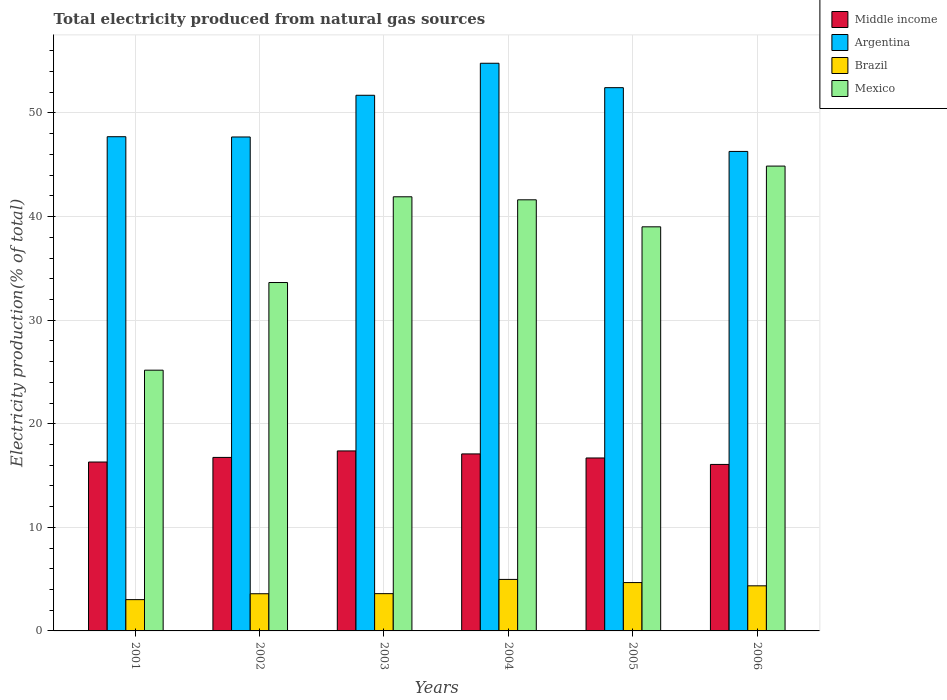How many different coloured bars are there?
Provide a succinct answer. 4. How many groups of bars are there?
Keep it short and to the point. 6. Are the number of bars per tick equal to the number of legend labels?
Ensure brevity in your answer.  Yes. Are the number of bars on each tick of the X-axis equal?
Give a very brief answer. Yes. In how many cases, is the number of bars for a given year not equal to the number of legend labels?
Your response must be concise. 0. What is the total electricity produced in Mexico in 2004?
Provide a short and direct response. 41.62. Across all years, what is the maximum total electricity produced in Argentina?
Your answer should be compact. 54.8. Across all years, what is the minimum total electricity produced in Argentina?
Keep it short and to the point. 46.29. In which year was the total electricity produced in Mexico maximum?
Make the answer very short. 2006. What is the total total electricity produced in Argentina in the graph?
Provide a succinct answer. 300.64. What is the difference between the total electricity produced in Brazil in 2001 and that in 2005?
Your answer should be very brief. -1.65. What is the difference between the total electricity produced in Brazil in 2001 and the total electricity produced in Argentina in 2004?
Provide a short and direct response. -51.78. What is the average total electricity produced in Mexico per year?
Provide a succinct answer. 37.7. In the year 2004, what is the difference between the total electricity produced in Argentina and total electricity produced in Mexico?
Offer a very short reply. 13.18. What is the ratio of the total electricity produced in Brazil in 2004 to that in 2005?
Offer a terse response. 1.07. Is the total electricity produced in Mexico in 2002 less than that in 2004?
Provide a short and direct response. Yes. What is the difference between the highest and the second highest total electricity produced in Argentina?
Provide a short and direct response. 2.36. What is the difference between the highest and the lowest total electricity produced in Middle income?
Make the answer very short. 1.3. Is the sum of the total electricity produced in Brazil in 2001 and 2005 greater than the maximum total electricity produced in Mexico across all years?
Make the answer very short. No. What does the 3rd bar from the left in 2003 represents?
Provide a succinct answer. Brazil. How many bars are there?
Keep it short and to the point. 24. Does the graph contain any zero values?
Provide a succinct answer. No. Where does the legend appear in the graph?
Make the answer very short. Top right. How many legend labels are there?
Your answer should be compact. 4. What is the title of the graph?
Your answer should be very brief. Total electricity produced from natural gas sources. Does "Ghana" appear as one of the legend labels in the graph?
Offer a terse response. No. What is the label or title of the X-axis?
Your answer should be very brief. Years. What is the label or title of the Y-axis?
Provide a short and direct response. Electricity production(% of total). What is the Electricity production(% of total) in Middle income in 2001?
Make the answer very short. 16.31. What is the Electricity production(% of total) of Argentina in 2001?
Your response must be concise. 47.71. What is the Electricity production(% of total) of Brazil in 2001?
Offer a terse response. 3.02. What is the Electricity production(% of total) in Mexico in 2001?
Offer a very short reply. 25.17. What is the Electricity production(% of total) in Middle income in 2002?
Provide a short and direct response. 16.75. What is the Electricity production(% of total) of Argentina in 2002?
Provide a short and direct response. 47.68. What is the Electricity production(% of total) of Brazil in 2002?
Keep it short and to the point. 3.59. What is the Electricity production(% of total) in Mexico in 2002?
Provide a short and direct response. 33.63. What is the Electricity production(% of total) of Middle income in 2003?
Your answer should be very brief. 17.38. What is the Electricity production(% of total) in Argentina in 2003?
Offer a very short reply. 51.71. What is the Electricity production(% of total) of Brazil in 2003?
Offer a terse response. 3.6. What is the Electricity production(% of total) of Mexico in 2003?
Your answer should be very brief. 41.91. What is the Electricity production(% of total) of Middle income in 2004?
Keep it short and to the point. 17.09. What is the Electricity production(% of total) of Argentina in 2004?
Your response must be concise. 54.8. What is the Electricity production(% of total) of Brazil in 2004?
Offer a terse response. 4.97. What is the Electricity production(% of total) in Mexico in 2004?
Provide a succinct answer. 41.62. What is the Electricity production(% of total) of Middle income in 2005?
Offer a terse response. 16.7. What is the Electricity production(% of total) in Argentina in 2005?
Your answer should be very brief. 52.45. What is the Electricity production(% of total) of Brazil in 2005?
Your answer should be compact. 4.67. What is the Electricity production(% of total) in Mexico in 2005?
Your answer should be very brief. 39.01. What is the Electricity production(% of total) of Middle income in 2006?
Provide a succinct answer. 16.07. What is the Electricity production(% of total) in Argentina in 2006?
Your answer should be compact. 46.29. What is the Electricity production(% of total) in Brazil in 2006?
Offer a very short reply. 4.35. What is the Electricity production(% of total) in Mexico in 2006?
Offer a terse response. 44.88. Across all years, what is the maximum Electricity production(% of total) of Middle income?
Provide a short and direct response. 17.38. Across all years, what is the maximum Electricity production(% of total) in Argentina?
Offer a terse response. 54.8. Across all years, what is the maximum Electricity production(% of total) in Brazil?
Ensure brevity in your answer.  4.97. Across all years, what is the maximum Electricity production(% of total) in Mexico?
Give a very brief answer. 44.88. Across all years, what is the minimum Electricity production(% of total) in Middle income?
Keep it short and to the point. 16.07. Across all years, what is the minimum Electricity production(% of total) in Argentina?
Make the answer very short. 46.29. Across all years, what is the minimum Electricity production(% of total) in Brazil?
Provide a succinct answer. 3.02. Across all years, what is the minimum Electricity production(% of total) of Mexico?
Give a very brief answer. 25.17. What is the total Electricity production(% of total) of Middle income in the graph?
Give a very brief answer. 100.29. What is the total Electricity production(% of total) of Argentina in the graph?
Make the answer very short. 300.64. What is the total Electricity production(% of total) of Brazil in the graph?
Offer a terse response. 24.2. What is the total Electricity production(% of total) in Mexico in the graph?
Offer a very short reply. 226.22. What is the difference between the Electricity production(% of total) in Middle income in 2001 and that in 2002?
Provide a succinct answer. -0.44. What is the difference between the Electricity production(% of total) of Argentina in 2001 and that in 2002?
Your answer should be very brief. 0.03. What is the difference between the Electricity production(% of total) of Brazil in 2001 and that in 2002?
Ensure brevity in your answer.  -0.57. What is the difference between the Electricity production(% of total) of Mexico in 2001 and that in 2002?
Ensure brevity in your answer.  -8.46. What is the difference between the Electricity production(% of total) of Middle income in 2001 and that in 2003?
Provide a succinct answer. -1.07. What is the difference between the Electricity production(% of total) of Argentina in 2001 and that in 2003?
Your response must be concise. -4. What is the difference between the Electricity production(% of total) of Brazil in 2001 and that in 2003?
Ensure brevity in your answer.  -0.58. What is the difference between the Electricity production(% of total) of Mexico in 2001 and that in 2003?
Your answer should be compact. -16.74. What is the difference between the Electricity production(% of total) of Middle income in 2001 and that in 2004?
Provide a succinct answer. -0.78. What is the difference between the Electricity production(% of total) in Argentina in 2001 and that in 2004?
Your answer should be very brief. -7.09. What is the difference between the Electricity production(% of total) of Brazil in 2001 and that in 2004?
Offer a terse response. -1.95. What is the difference between the Electricity production(% of total) of Mexico in 2001 and that in 2004?
Offer a very short reply. -16.45. What is the difference between the Electricity production(% of total) of Middle income in 2001 and that in 2005?
Offer a very short reply. -0.39. What is the difference between the Electricity production(% of total) in Argentina in 2001 and that in 2005?
Offer a terse response. -4.73. What is the difference between the Electricity production(% of total) in Brazil in 2001 and that in 2005?
Offer a terse response. -1.65. What is the difference between the Electricity production(% of total) of Mexico in 2001 and that in 2005?
Your answer should be compact. -13.84. What is the difference between the Electricity production(% of total) of Middle income in 2001 and that in 2006?
Ensure brevity in your answer.  0.23. What is the difference between the Electricity production(% of total) in Argentina in 2001 and that in 2006?
Your response must be concise. 1.42. What is the difference between the Electricity production(% of total) of Brazil in 2001 and that in 2006?
Your answer should be compact. -1.33. What is the difference between the Electricity production(% of total) in Mexico in 2001 and that in 2006?
Your answer should be very brief. -19.7. What is the difference between the Electricity production(% of total) of Middle income in 2002 and that in 2003?
Your response must be concise. -0.63. What is the difference between the Electricity production(% of total) of Argentina in 2002 and that in 2003?
Ensure brevity in your answer.  -4.03. What is the difference between the Electricity production(% of total) of Brazil in 2002 and that in 2003?
Offer a terse response. -0.01. What is the difference between the Electricity production(% of total) of Mexico in 2002 and that in 2003?
Provide a short and direct response. -8.28. What is the difference between the Electricity production(% of total) of Middle income in 2002 and that in 2004?
Your answer should be very brief. -0.34. What is the difference between the Electricity production(% of total) of Argentina in 2002 and that in 2004?
Offer a very short reply. -7.12. What is the difference between the Electricity production(% of total) of Brazil in 2002 and that in 2004?
Ensure brevity in your answer.  -1.38. What is the difference between the Electricity production(% of total) in Mexico in 2002 and that in 2004?
Your response must be concise. -7.98. What is the difference between the Electricity production(% of total) in Middle income in 2002 and that in 2005?
Your response must be concise. 0.05. What is the difference between the Electricity production(% of total) in Argentina in 2002 and that in 2005?
Provide a succinct answer. -4.76. What is the difference between the Electricity production(% of total) in Brazil in 2002 and that in 2005?
Ensure brevity in your answer.  -1.08. What is the difference between the Electricity production(% of total) in Mexico in 2002 and that in 2005?
Your answer should be very brief. -5.38. What is the difference between the Electricity production(% of total) in Middle income in 2002 and that in 2006?
Your answer should be compact. 0.68. What is the difference between the Electricity production(% of total) in Argentina in 2002 and that in 2006?
Your response must be concise. 1.39. What is the difference between the Electricity production(% of total) in Brazil in 2002 and that in 2006?
Your answer should be compact. -0.77. What is the difference between the Electricity production(% of total) in Mexico in 2002 and that in 2006?
Ensure brevity in your answer.  -11.24. What is the difference between the Electricity production(% of total) in Middle income in 2003 and that in 2004?
Make the answer very short. 0.29. What is the difference between the Electricity production(% of total) in Argentina in 2003 and that in 2004?
Keep it short and to the point. -3.09. What is the difference between the Electricity production(% of total) in Brazil in 2003 and that in 2004?
Give a very brief answer. -1.37. What is the difference between the Electricity production(% of total) of Mexico in 2003 and that in 2004?
Provide a short and direct response. 0.29. What is the difference between the Electricity production(% of total) in Middle income in 2003 and that in 2005?
Your answer should be compact. 0.68. What is the difference between the Electricity production(% of total) of Argentina in 2003 and that in 2005?
Make the answer very short. -0.74. What is the difference between the Electricity production(% of total) in Brazil in 2003 and that in 2005?
Your answer should be very brief. -1.07. What is the difference between the Electricity production(% of total) in Mexico in 2003 and that in 2005?
Provide a short and direct response. 2.9. What is the difference between the Electricity production(% of total) in Middle income in 2003 and that in 2006?
Ensure brevity in your answer.  1.3. What is the difference between the Electricity production(% of total) of Argentina in 2003 and that in 2006?
Offer a very short reply. 5.42. What is the difference between the Electricity production(% of total) of Brazil in 2003 and that in 2006?
Provide a short and direct response. -0.76. What is the difference between the Electricity production(% of total) in Mexico in 2003 and that in 2006?
Your answer should be compact. -2.96. What is the difference between the Electricity production(% of total) in Middle income in 2004 and that in 2005?
Your answer should be very brief. 0.39. What is the difference between the Electricity production(% of total) in Argentina in 2004 and that in 2005?
Provide a succinct answer. 2.36. What is the difference between the Electricity production(% of total) in Brazil in 2004 and that in 2005?
Your response must be concise. 0.3. What is the difference between the Electricity production(% of total) in Mexico in 2004 and that in 2005?
Provide a short and direct response. 2.61. What is the difference between the Electricity production(% of total) in Middle income in 2004 and that in 2006?
Your response must be concise. 1.02. What is the difference between the Electricity production(% of total) in Argentina in 2004 and that in 2006?
Your answer should be compact. 8.51. What is the difference between the Electricity production(% of total) in Brazil in 2004 and that in 2006?
Your response must be concise. 0.62. What is the difference between the Electricity production(% of total) of Mexico in 2004 and that in 2006?
Ensure brevity in your answer.  -3.26. What is the difference between the Electricity production(% of total) of Middle income in 2005 and that in 2006?
Keep it short and to the point. 0.62. What is the difference between the Electricity production(% of total) of Argentina in 2005 and that in 2006?
Offer a very short reply. 6.16. What is the difference between the Electricity production(% of total) in Brazil in 2005 and that in 2006?
Provide a succinct answer. 0.31. What is the difference between the Electricity production(% of total) of Mexico in 2005 and that in 2006?
Offer a very short reply. -5.86. What is the difference between the Electricity production(% of total) in Middle income in 2001 and the Electricity production(% of total) in Argentina in 2002?
Ensure brevity in your answer.  -31.38. What is the difference between the Electricity production(% of total) in Middle income in 2001 and the Electricity production(% of total) in Brazil in 2002?
Ensure brevity in your answer.  12.72. What is the difference between the Electricity production(% of total) of Middle income in 2001 and the Electricity production(% of total) of Mexico in 2002?
Keep it short and to the point. -17.33. What is the difference between the Electricity production(% of total) in Argentina in 2001 and the Electricity production(% of total) in Brazil in 2002?
Your answer should be very brief. 44.12. What is the difference between the Electricity production(% of total) in Argentina in 2001 and the Electricity production(% of total) in Mexico in 2002?
Your answer should be very brief. 14.08. What is the difference between the Electricity production(% of total) in Brazil in 2001 and the Electricity production(% of total) in Mexico in 2002?
Keep it short and to the point. -30.61. What is the difference between the Electricity production(% of total) in Middle income in 2001 and the Electricity production(% of total) in Argentina in 2003?
Your answer should be very brief. -35.4. What is the difference between the Electricity production(% of total) of Middle income in 2001 and the Electricity production(% of total) of Brazil in 2003?
Make the answer very short. 12.71. What is the difference between the Electricity production(% of total) of Middle income in 2001 and the Electricity production(% of total) of Mexico in 2003?
Provide a short and direct response. -25.61. What is the difference between the Electricity production(% of total) in Argentina in 2001 and the Electricity production(% of total) in Brazil in 2003?
Ensure brevity in your answer.  44.11. What is the difference between the Electricity production(% of total) in Brazil in 2001 and the Electricity production(% of total) in Mexico in 2003?
Provide a short and direct response. -38.89. What is the difference between the Electricity production(% of total) in Middle income in 2001 and the Electricity production(% of total) in Argentina in 2004?
Provide a succinct answer. -38.5. What is the difference between the Electricity production(% of total) in Middle income in 2001 and the Electricity production(% of total) in Brazil in 2004?
Ensure brevity in your answer.  11.33. What is the difference between the Electricity production(% of total) in Middle income in 2001 and the Electricity production(% of total) in Mexico in 2004?
Your response must be concise. -25.31. What is the difference between the Electricity production(% of total) in Argentina in 2001 and the Electricity production(% of total) in Brazil in 2004?
Offer a terse response. 42.74. What is the difference between the Electricity production(% of total) of Argentina in 2001 and the Electricity production(% of total) of Mexico in 2004?
Ensure brevity in your answer.  6.09. What is the difference between the Electricity production(% of total) of Brazil in 2001 and the Electricity production(% of total) of Mexico in 2004?
Offer a terse response. -38.6. What is the difference between the Electricity production(% of total) in Middle income in 2001 and the Electricity production(% of total) in Argentina in 2005?
Ensure brevity in your answer.  -36.14. What is the difference between the Electricity production(% of total) of Middle income in 2001 and the Electricity production(% of total) of Brazil in 2005?
Give a very brief answer. 11.64. What is the difference between the Electricity production(% of total) of Middle income in 2001 and the Electricity production(% of total) of Mexico in 2005?
Your answer should be very brief. -22.71. What is the difference between the Electricity production(% of total) in Argentina in 2001 and the Electricity production(% of total) in Brazil in 2005?
Make the answer very short. 43.04. What is the difference between the Electricity production(% of total) in Argentina in 2001 and the Electricity production(% of total) in Mexico in 2005?
Offer a terse response. 8.7. What is the difference between the Electricity production(% of total) in Brazil in 2001 and the Electricity production(% of total) in Mexico in 2005?
Provide a succinct answer. -35.99. What is the difference between the Electricity production(% of total) in Middle income in 2001 and the Electricity production(% of total) in Argentina in 2006?
Provide a short and direct response. -29.98. What is the difference between the Electricity production(% of total) of Middle income in 2001 and the Electricity production(% of total) of Brazil in 2006?
Your response must be concise. 11.95. What is the difference between the Electricity production(% of total) of Middle income in 2001 and the Electricity production(% of total) of Mexico in 2006?
Offer a terse response. -28.57. What is the difference between the Electricity production(% of total) of Argentina in 2001 and the Electricity production(% of total) of Brazil in 2006?
Your response must be concise. 43.36. What is the difference between the Electricity production(% of total) in Argentina in 2001 and the Electricity production(% of total) in Mexico in 2006?
Provide a short and direct response. 2.84. What is the difference between the Electricity production(% of total) in Brazil in 2001 and the Electricity production(% of total) in Mexico in 2006?
Your answer should be compact. -41.85. What is the difference between the Electricity production(% of total) of Middle income in 2002 and the Electricity production(% of total) of Argentina in 2003?
Offer a very short reply. -34.96. What is the difference between the Electricity production(% of total) in Middle income in 2002 and the Electricity production(% of total) in Brazil in 2003?
Keep it short and to the point. 13.15. What is the difference between the Electricity production(% of total) of Middle income in 2002 and the Electricity production(% of total) of Mexico in 2003?
Give a very brief answer. -25.16. What is the difference between the Electricity production(% of total) of Argentina in 2002 and the Electricity production(% of total) of Brazil in 2003?
Offer a very short reply. 44.09. What is the difference between the Electricity production(% of total) of Argentina in 2002 and the Electricity production(% of total) of Mexico in 2003?
Offer a very short reply. 5.77. What is the difference between the Electricity production(% of total) of Brazil in 2002 and the Electricity production(% of total) of Mexico in 2003?
Ensure brevity in your answer.  -38.32. What is the difference between the Electricity production(% of total) in Middle income in 2002 and the Electricity production(% of total) in Argentina in 2004?
Offer a terse response. -38.05. What is the difference between the Electricity production(% of total) in Middle income in 2002 and the Electricity production(% of total) in Brazil in 2004?
Ensure brevity in your answer.  11.78. What is the difference between the Electricity production(% of total) in Middle income in 2002 and the Electricity production(% of total) in Mexico in 2004?
Provide a succinct answer. -24.87. What is the difference between the Electricity production(% of total) of Argentina in 2002 and the Electricity production(% of total) of Brazil in 2004?
Offer a very short reply. 42.71. What is the difference between the Electricity production(% of total) of Argentina in 2002 and the Electricity production(% of total) of Mexico in 2004?
Provide a succinct answer. 6.07. What is the difference between the Electricity production(% of total) of Brazil in 2002 and the Electricity production(% of total) of Mexico in 2004?
Your answer should be very brief. -38.03. What is the difference between the Electricity production(% of total) in Middle income in 2002 and the Electricity production(% of total) in Argentina in 2005?
Your response must be concise. -35.7. What is the difference between the Electricity production(% of total) in Middle income in 2002 and the Electricity production(% of total) in Brazil in 2005?
Ensure brevity in your answer.  12.08. What is the difference between the Electricity production(% of total) in Middle income in 2002 and the Electricity production(% of total) in Mexico in 2005?
Offer a very short reply. -22.26. What is the difference between the Electricity production(% of total) of Argentina in 2002 and the Electricity production(% of total) of Brazil in 2005?
Provide a short and direct response. 43.02. What is the difference between the Electricity production(% of total) in Argentina in 2002 and the Electricity production(% of total) in Mexico in 2005?
Make the answer very short. 8.67. What is the difference between the Electricity production(% of total) in Brazil in 2002 and the Electricity production(% of total) in Mexico in 2005?
Make the answer very short. -35.42. What is the difference between the Electricity production(% of total) in Middle income in 2002 and the Electricity production(% of total) in Argentina in 2006?
Keep it short and to the point. -29.54. What is the difference between the Electricity production(% of total) in Middle income in 2002 and the Electricity production(% of total) in Brazil in 2006?
Give a very brief answer. 12.4. What is the difference between the Electricity production(% of total) of Middle income in 2002 and the Electricity production(% of total) of Mexico in 2006?
Offer a terse response. -28.13. What is the difference between the Electricity production(% of total) of Argentina in 2002 and the Electricity production(% of total) of Brazil in 2006?
Provide a succinct answer. 43.33. What is the difference between the Electricity production(% of total) in Argentina in 2002 and the Electricity production(% of total) in Mexico in 2006?
Make the answer very short. 2.81. What is the difference between the Electricity production(% of total) in Brazil in 2002 and the Electricity production(% of total) in Mexico in 2006?
Your response must be concise. -41.29. What is the difference between the Electricity production(% of total) of Middle income in 2003 and the Electricity production(% of total) of Argentina in 2004?
Make the answer very short. -37.42. What is the difference between the Electricity production(% of total) in Middle income in 2003 and the Electricity production(% of total) in Brazil in 2004?
Provide a succinct answer. 12.4. What is the difference between the Electricity production(% of total) in Middle income in 2003 and the Electricity production(% of total) in Mexico in 2004?
Provide a short and direct response. -24.24. What is the difference between the Electricity production(% of total) in Argentina in 2003 and the Electricity production(% of total) in Brazil in 2004?
Offer a terse response. 46.74. What is the difference between the Electricity production(% of total) of Argentina in 2003 and the Electricity production(% of total) of Mexico in 2004?
Keep it short and to the point. 10.09. What is the difference between the Electricity production(% of total) of Brazil in 2003 and the Electricity production(% of total) of Mexico in 2004?
Your response must be concise. -38.02. What is the difference between the Electricity production(% of total) of Middle income in 2003 and the Electricity production(% of total) of Argentina in 2005?
Make the answer very short. -35.07. What is the difference between the Electricity production(% of total) in Middle income in 2003 and the Electricity production(% of total) in Brazil in 2005?
Your answer should be very brief. 12.71. What is the difference between the Electricity production(% of total) of Middle income in 2003 and the Electricity production(% of total) of Mexico in 2005?
Provide a succinct answer. -21.63. What is the difference between the Electricity production(% of total) of Argentina in 2003 and the Electricity production(% of total) of Brazil in 2005?
Offer a very short reply. 47.04. What is the difference between the Electricity production(% of total) of Argentina in 2003 and the Electricity production(% of total) of Mexico in 2005?
Provide a succinct answer. 12.7. What is the difference between the Electricity production(% of total) of Brazil in 2003 and the Electricity production(% of total) of Mexico in 2005?
Keep it short and to the point. -35.41. What is the difference between the Electricity production(% of total) in Middle income in 2003 and the Electricity production(% of total) in Argentina in 2006?
Your answer should be compact. -28.91. What is the difference between the Electricity production(% of total) in Middle income in 2003 and the Electricity production(% of total) in Brazil in 2006?
Ensure brevity in your answer.  13.02. What is the difference between the Electricity production(% of total) in Middle income in 2003 and the Electricity production(% of total) in Mexico in 2006?
Offer a terse response. -27.5. What is the difference between the Electricity production(% of total) in Argentina in 2003 and the Electricity production(% of total) in Brazil in 2006?
Offer a terse response. 47.36. What is the difference between the Electricity production(% of total) of Argentina in 2003 and the Electricity production(% of total) of Mexico in 2006?
Keep it short and to the point. 6.84. What is the difference between the Electricity production(% of total) of Brazil in 2003 and the Electricity production(% of total) of Mexico in 2006?
Ensure brevity in your answer.  -41.28. What is the difference between the Electricity production(% of total) of Middle income in 2004 and the Electricity production(% of total) of Argentina in 2005?
Your answer should be compact. -35.36. What is the difference between the Electricity production(% of total) in Middle income in 2004 and the Electricity production(% of total) in Brazil in 2005?
Your answer should be compact. 12.42. What is the difference between the Electricity production(% of total) in Middle income in 2004 and the Electricity production(% of total) in Mexico in 2005?
Provide a succinct answer. -21.92. What is the difference between the Electricity production(% of total) in Argentina in 2004 and the Electricity production(% of total) in Brazil in 2005?
Make the answer very short. 50.13. What is the difference between the Electricity production(% of total) in Argentina in 2004 and the Electricity production(% of total) in Mexico in 2005?
Offer a terse response. 15.79. What is the difference between the Electricity production(% of total) of Brazil in 2004 and the Electricity production(% of total) of Mexico in 2005?
Provide a short and direct response. -34.04. What is the difference between the Electricity production(% of total) of Middle income in 2004 and the Electricity production(% of total) of Argentina in 2006?
Your response must be concise. -29.2. What is the difference between the Electricity production(% of total) of Middle income in 2004 and the Electricity production(% of total) of Brazil in 2006?
Make the answer very short. 12.73. What is the difference between the Electricity production(% of total) of Middle income in 2004 and the Electricity production(% of total) of Mexico in 2006?
Ensure brevity in your answer.  -27.79. What is the difference between the Electricity production(% of total) of Argentina in 2004 and the Electricity production(% of total) of Brazil in 2006?
Keep it short and to the point. 50.45. What is the difference between the Electricity production(% of total) of Argentina in 2004 and the Electricity production(% of total) of Mexico in 2006?
Ensure brevity in your answer.  9.93. What is the difference between the Electricity production(% of total) in Brazil in 2004 and the Electricity production(% of total) in Mexico in 2006?
Your answer should be compact. -39.9. What is the difference between the Electricity production(% of total) of Middle income in 2005 and the Electricity production(% of total) of Argentina in 2006?
Ensure brevity in your answer.  -29.59. What is the difference between the Electricity production(% of total) of Middle income in 2005 and the Electricity production(% of total) of Brazil in 2006?
Offer a very short reply. 12.34. What is the difference between the Electricity production(% of total) in Middle income in 2005 and the Electricity production(% of total) in Mexico in 2006?
Offer a terse response. -28.18. What is the difference between the Electricity production(% of total) of Argentina in 2005 and the Electricity production(% of total) of Brazil in 2006?
Ensure brevity in your answer.  48.09. What is the difference between the Electricity production(% of total) in Argentina in 2005 and the Electricity production(% of total) in Mexico in 2006?
Ensure brevity in your answer.  7.57. What is the difference between the Electricity production(% of total) in Brazil in 2005 and the Electricity production(% of total) in Mexico in 2006?
Offer a very short reply. -40.21. What is the average Electricity production(% of total) in Middle income per year?
Give a very brief answer. 16.71. What is the average Electricity production(% of total) of Argentina per year?
Your answer should be compact. 50.11. What is the average Electricity production(% of total) of Brazil per year?
Your response must be concise. 4.03. What is the average Electricity production(% of total) in Mexico per year?
Ensure brevity in your answer.  37.7. In the year 2001, what is the difference between the Electricity production(% of total) in Middle income and Electricity production(% of total) in Argentina?
Make the answer very short. -31.41. In the year 2001, what is the difference between the Electricity production(% of total) of Middle income and Electricity production(% of total) of Brazil?
Provide a succinct answer. 13.29. In the year 2001, what is the difference between the Electricity production(% of total) in Middle income and Electricity production(% of total) in Mexico?
Make the answer very short. -8.87. In the year 2001, what is the difference between the Electricity production(% of total) of Argentina and Electricity production(% of total) of Brazil?
Provide a succinct answer. 44.69. In the year 2001, what is the difference between the Electricity production(% of total) in Argentina and Electricity production(% of total) in Mexico?
Your response must be concise. 22.54. In the year 2001, what is the difference between the Electricity production(% of total) of Brazil and Electricity production(% of total) of Mexico?
Ensure brevity in your answer.  -22.15. In the year 2002, what is the difference between the Electricity production(% of total) in Middle income and Electricity production(% of total) in Argentina?
Provide a short and direct response. -30.93. In the year 2002, what is the difference between the Electricity production(% of total) in Middle income and Electricity production(% of total) in Brazil?
Your response must be concise. 13.16. In the year 2002, what is the difference between the Electricity production(% of total) of Middle income and Electricity production(% of total) of Mexico?
Provide a succinct answer. -16.88. In the year 2002, what is the difference between the Electricity production(% of total) in Argentina and Electricity production(% of total) in Brazil?
Provide a succinct answer. 44.1. In the year 2002, what is the difference between the Electricity production(% of total) of Argentina and Electricity production(% of total) of Mexico?
Your answer should be compact. 14.05. In the year 2002, what is the difference between the Electricity production(% of total) of Brazil and Electricity production(% of total) of Mexico?
Your response must be concise. -30.05. In the year 2003, what is the difference between the Electricity production(% of total) of Middle income and Electricity production(% of total) of Argentina?
Provide a short and direct response. -34.33. In the year 2003, what is the difference between the Electricity production(% of total) of Middle income and Electricity production(% of total) of Brazil?
Offer a very short reply. 13.78. In the year 2003, what is the difference between the Electricity production(% of total) of Middle income and Electricity production(% of total) of Mexico?
Give a very brief answer. -24.53. In the year 2003, what is the difference between the Electricity production(% of total) in Argentina and Electricity production(% of total) in Brazil?
Offer a very short reply. 48.11. In the year 2003, what is the difference between the Electricity production(% of total) of Argentina and Electricity production(% of total) of Mexico?
Your answer should be very brief. 9.8. In the year 2003, what is the difference between the Electricity production(% of total) of Brazil and Electricity production(% of total) of Mexico?
Give a very brief answer. -38.31. In the year 2004, what is the difference between the Electricity production(% of total) of Middle income and Electricity production(% of total) of Argentina?
Your response must be concise. -37.71. In the year 2004, what is the difference between the Electricity production(% of total) in Middle income and Electricity production(% of total) in Brazil?
Your response must be concise. 12.12. In the year 2004, what is the difference between the Electricity production(% of total) of Middle income and Electricity production(% of total) of Mexico?
Ensure brevity in your answer.  -24.53. In the year 2004, what is the difference between the Electricity production(% of total) of Argentina and Electricity production(% of total) of Brazil?
Make the answer very short. 49.83. In the year 2004, what is the difference between the Electricity production(% of total) of Argentina and Electricity production(% of total) of Mexico?
Your answer should be very brief. 13.18. In the year 2004, what is the difference between the Electricity production(% of total) in Brazil and Electricity production(% of total) in Mexico?
Offer a terse response. -36.65. In the year 2005, what is the difference between the Electricity production(% of total) of Middle income and Electricity production(% of total) of Argentina?
Keep it short and to the point. -35.75. In the year 2005, what is the difference between the Electricity production(% of total) in Middle income and Electricity production(% of total) in Brazil?
Your answer should be compact. 12.03. In the year 2005, what is the difference between the Electricity production(% of total) of Middle income and Electricity production(% of total) of Mexico?
Keep it short and to the point. -22.31. In the year 2005, what is the difference between the Electricity production(% of total) in Argentina and Electricity production(% of total) in Brazil?
Keep it short and to the point. 47.78. In the year 2005, what is the difference between the Electricity production(% of total) of Argentina and Electricity production(% of total) of Mexico?
Keep it short and to the point. 13.44. In the year 2005, what is the difference between the Electricity production(% of total) of Brazil and Electricity production(% of total) of Mexico?
Provide a succinct answer. -34.34. In the year 2006, what is the difference between the Electricity production(% of total) of Middle income and Electricity production(% of total) of Argentina?
Your answer should be compact. -30.22. In the year 2006, what is the difference between the Electricity production(% of total) in Middle income and Electricity production(% of total) in Brazil?
Keep it short and to the point. 11.72. In the year 2006, what is the difference between the Electricity production(% of total) in Middle income and Electricity production(% of total) in Mexico?
Your answer should be very brief. -28.8. In the year 2006, what is the difference between the Electricity production(% of total) in Argentina and Electricity production(% of total) in Brazil?
Offer a very short reply. 41.94. In the year 2006, what is the difference between the Electricity production(% of total) of Argentina and Electricity production(% of total) of Mexico?
Your answer should be very brief. 1.42. In the year 2006, what is the difference between the Electricity production(% of total) in Brazil and Electricity production(% of total) in Mexico?
Offer a terse response. -40.52. What is the ratio of the Electricity production(% of total) of Middle income in 2001 to that in 2002?
Provide a short and direct response. 0.97. What is the ratio of the Electricity production(% of total) of Brazil in 2001 to that in 2002?
Offer a terse response. 0.84. What is the ratio of the Electricity production(% of total) in Mexico in 2001 to that in 2002?
Provide a succinct answer. 0.75. What is the ratio of the Electricity production(% of total) in Middle income in 2001 to that in 2003?
Provide a succinct answer. 0.94. What is the ratio of the Electricity production(% of total) of Argentina in 2001 to that in 2003?
Ensure brevity in your answer.  0.92. What is the ratio of the Electricity production(% of total) of Brazil in 2001 to that in 2003?
Make the answer very short. 0.84. What is the ratio of the Electricity production(% of total) of Mexico in 2001 to that in 2003?
Ensure brevity in your answer.  0.6. What is the ratio of the Electricity production(% of total) of Middle income in 2001 to that in 2004?
Your response must be concise. 0.95. What is the ratio of the Electricity production(% of total) in Argentina in 2001 to that in 2004?
Offer a terse response. 0.87. What is the ratio of the Electricity production(% of total) of Brazil in 2001 to that in 2004?
Offer a terse response. 0.61. What is the ratio of the Electricity production(% of total) of Mexico in 2001 to that in 2004?
Provide a short and direct response. 0.6. What is the ratio of the Electricity production(% of total) of Middle income in 2001 to that in 2005?
Keep it short and to the point. 0.98. What is the ratio of the Electricity production(% of total) in Argentina in 2001 to that in 2005?
Offer a terse response. 0.91. What is the ratio of the Electricity production(% of total) of Brazil in 2001 to that in 2005?
Your response must be concise. 0.65. What is the ratio of the Electricity production(% of total) in Mexico in 2001 to that in 2005?
Your answer should be very brief. 0.65. What is the ratio of the Electricity production(% of total) of Middle income in 2001 to that in 2006?
Your answer should be very brief. 1.01. What is the ratio of the Electricity production(% of total) of Argentina in 2001 to that in 2006?
Ensure brevity in your answer.  1.03. What is the ratio of the Electricity production(% of total) in Brazil in 2001 to that in 2006?
Provide a short and direct response. 0.69. What is the ratio of the Electricity production(% of total) in Mexico in 2001 to that in 2006?
Keep it short and to the point. 0.56. What is the ratio of the Electricity production(% of total) of Middle income in 2002 to that in 2003?
Keep it short and to the point. 0.96. What is the ratio of the Electricity production(% of total) of Argentina in 2002 to that in 2003?
Make the answer very short. 0.92. What is the ratio of the Electricity production(% of total) in Mexico in 2002 to that in 2003?
Provide a succinct answer. 0.8. What is the ratio of the Electricity production(% of total) of Middle income in 2002 to that in 2004?
Offer a very short reply. 0.98. What is the ratio of the Electricity production(% of total) in Argentina in 2002 to that in 2004?
Provide a succinct answer. 0.87. What is the ratio of the Electricity production(% of total) of Brazil in 2002 to that in 2004?
Give a very brief answer. 0.72. What is the ratio of the Electricity production(% of total) of Mexico in 2002 to that in 2004?
Your answer should be very brief. 0.81. What is the ratio of the Electricity production(% of total) of Middle income in 2002 to that in 2005?
Offer a terse response. 1. What is the ratio of the Electricity production(% of total) of Argentina in 2002 to that in 2005?
Your response must be concise. 0.91. What is the ratio of the Electricity production(% of total) of Brazil in 2002 to that in 2005?
Offer a terse response. 0.77. What is the ratio of the Electricity production(% of total) of Mexico in 2002 to that in 2005?
Provide a succinct answer. 0.86. What is the ratio of the Electricity production(% of total) of Middle income in 2002 to that in 2006?
Provide a succinct answer. 1.04. What is the ratio of the Electricity production(% of total) in Argentina in 2002 to that in 2006?
Give a very brief answer. 1.03. What is the ratio of the Electricity production(% of total) of Brazil in 2002 to that in 2006?
Provide a short and direct response. 0.82. What is the ratio of the Electricity production(% of total) in Mexico in 2002 to that in 2006?
Provide a short and direct response. 0.75. What is the ratio of the Electricity production(% of total) of Middle income in 2003 to that in 2004?
Your answer should be very brief. 1.02. What is the ratio of the Electricity production(% of total) of Argentina in 2003 to that in 2004?
Provide a succinct answer. 0.94. What is the ratio of the Electricity production(% of total) of Brazil in 2003 to that in 2004?
Keep it short and to the point. 0.72. What is the ratio of the Electricity production(% of total) in Middle income in 2003 to that in 2005?
Keep it short and to the point. 1.04. What is the ratio of the Electricity production(% of total) in Argentina in 2003 to that in 2005?
Your answer should be very brief. 0.99. What is the ratio of the Electricity production(% of total) of Brazil in 2003 to that in 2005?
Your answer should be very brief. 0.77. What is the ratio of the Electricity production(% of total) of Mexico in 2003 to that in 2005?
Your answer should be very brief. 1.07. What is the ratio of the Electricity production(% of total) of Middle income in 2003 to that in 2006?
Make the answer very short. 1.08. What is the ratio of the Electricity production(% of total) in Argentina in 2003 to that in 2006?
Keep it short and to the point. 1.12. What is the ratio of the Electricity production(% of total) in Brazil in 2003 to that in 2006?
Offer a very short reply. 0.83. What is the ratio of the Electricity production(% of total) of Mexico in 2003 to that in 2006?
Your response must be concise. 0.93. What is the ratio of the Electricity production(% of total) in Middle income in 2004 to that in 2005?
Provide a succinct answer. 1.02. What is the ratio of the Electricity production(% of total) in Argentina in 2004 to that in 2005?
Ensure brevity in your answer.  1.04. What is the ratio of the Electricity production(% of total) of Brazil in 2004 to that in 2005?
Give a very brief answer. 1.07. What is the ratio of the Electricity production(% of total) of Mexico in 2004 to that in 2005?
Keep it short and to the point. 1.07. What is the ratio of the Electricity production(% of total) of Middle income in 2004 to that in 2006?
Ensure brevity in your answer.  1.06. What is the ratio of the Electricity production(% of total) of Argentina in 2004 to that in 2006?
Ensure brevity in your answer.  1.18. What is the ratio of the Electricity production(% of total) of Brazil in 2004 to that in 2006?
Offer a very short reply. 1.14. What is the ratio of the Electricity production(% of total) in Mexico in 2004 to that in 2006?
Provide a succinct answer. 0.93. What is the ratio of the Electricity production(% of total) in Middle income in 2005 to that in 2006?
Your answer should be very brief. 1.04. What is the ratio of the Electricity production(% of total) of Argentina in 2005 to that in 2006?
Ensure brevity in your answer.  1.13. What is the ratio of the Electricity production(% of total) in Brazil in 2005 to that in 2006?
Make the answer very short. 1.07. What is the ratio of the Electricity production(% of total) in Mexico in 2005 to that in 2006?
Give a very brief answer. 0.87. What is the difference between the highest and the second highest Electricity production(% of total) of Middle income?
Make the answer very short. 0.29. What is the difference between the highest and the second highest Electricity production(% of total) of Argentina?
Ensure brevity in your answer.  2.36. What is the difference between the highest and the second highest Electricity production(% of total) in Brazil?
Your answer should be compact. 0.3. What is the difference between the highest and the second highest Electricity production(% of total) in Mexico?
Your answer should be compact. 2.96. What is the difference between the highest and the lowest Electricity production(% of total) in Middle income?
Keep it short and to the point. 1.3. What is the difference between the highest and the lowest Electricity production(% of total) in Argentina?
Keep it short and to the point. 8.51. What is the difference between the highest and the lowest Electricity production(% of total) in Brazil?
Your answer should be very brief. 1.95. What is the difference between the highest and the lowest Electricity production(% of total) of Mexico?
Provide a short and direct response. 19.7. 